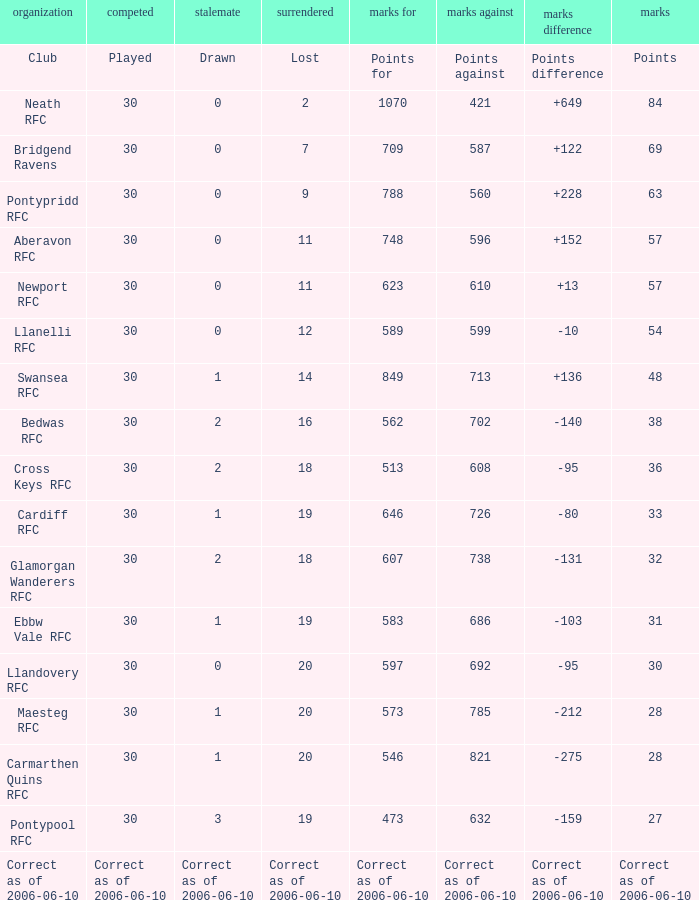What is Points, when Points For is "562"? 38.0. 